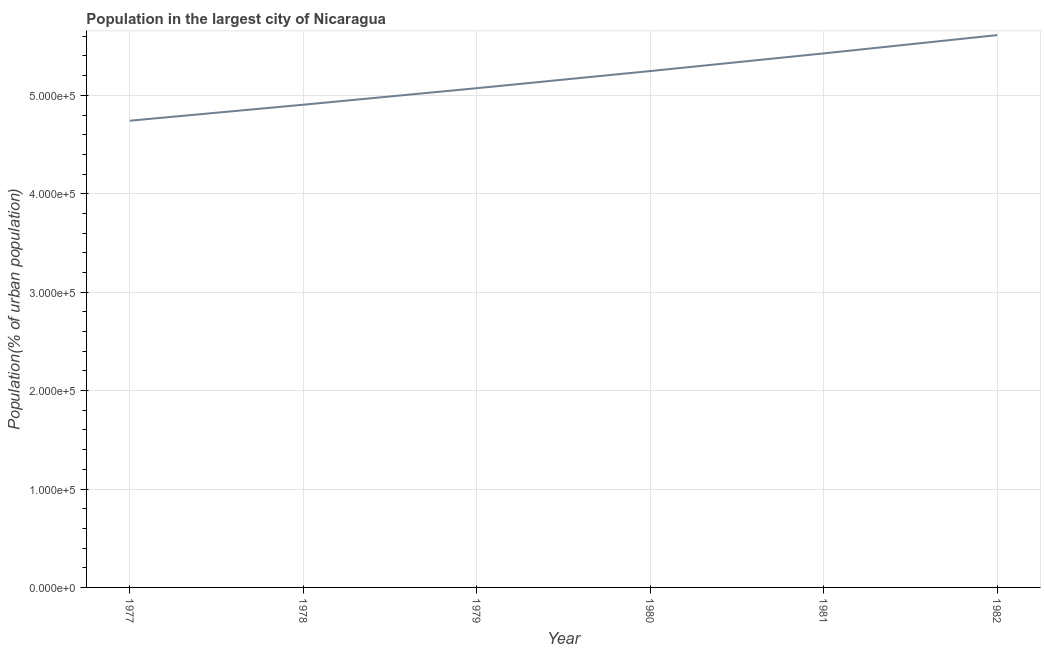What is the population in largest city in 1978?
Offer a terse response. 4.90e+05. Across all years, what is the maximum population in largest city?
Give a very brief answer. 5.61e+05. Across all years, what is the minimum population in largest city?
Your response must be concise. 4.74e+05. In which year was the population in largest city maximum?
Provide a succinct answer. 1982. In which year was the population in largest city minimum?
Offer a terse response. 1977. What is the sum of the population in largest city?
Offer a very short reply. 3.10e+06. What is the difference between the population in largest city in 1978 and 1982?
Your answer should be compact. -7.07e+04. What is the average population in largest city per year?
Keep it short and to the point. 5.17e+05. What is the median population in largest city?
Make the answer very short. 5.16e+05. In how many years, is the population in largest city greater than 60000 %?
Give a very brief answer. 6. Do a majority of the years between 1977 and 1981 (inclusive) have population in largest city greater than 480000 %?
Your answer should be compact. Yes. What is the ratio of the population in largest city in 1977 to that in 1979?
Ensure brevity in your answer.  0.93. Is the difference between the population in largest city in 1978 and 1980 greater than the difference between any two years?
Provide a succinct answer. No. What is the difference between the highest and the second highest population in largest city?
Your answer should be very brief. 1.86e+04. Is the sum of the population in largest city in 1977 and 1979 greater than the maximum population in largest city across all years?
Give a very brief answer. Yes. What is the difference between the highest and the lowest population in largest city?
Offer a very short reply. 8.70e+04. In how many years, is the population in largest city greater than the average population in largest city taken over all years?
Your response must be concise. 3. How many lines are there?
Your response must be concise. 1. How many years are there in the graph?
Your answer should be compact. 6. Are the values on the major ticks of Y-axis written in scientific E-notation?
Your response must be concise. Yes. Does the graph contain grids?
Keep it short and to the point. Yes. What is the title of the graph?
Keep it short and to the point. Population in the largest city of Nicaragua. What is the label or title of the Y-axis?
Your answer should be very brief. Population(% of urban population). What is the Population(% of urban population) in 1977?
Your answer should be very brief. 4.74e+05. What is the Population(% of urban population) of 1978?
Your response must be concise. 4.90e+05. What is the Population(% of urban population) of 1979?
Give a very brief answer. 5.07e+05. What is the Population(% of urban population) of 1980?
Provide a succinct answer. 5.25e+05. What is the Population(% of urban population) in 1981?
Provide a succinct answer. 5.43e+05. What is the Population(% of urban population) in 1982?
Keep it short and to the point. 5.61e+05. What is the difference between the Population(% of urban population) in 1977 and 1978?
Offer a terse response. -1.62e+04. What is the difference between the Population(% of urban population) in 1977 and 1979?
Give a very brief answer. -3.30e+04. What is the difference between the Population(% of urban population) in 1977 and 1980?
Keep it short and to the point. -5.04e+04. What is the difference between the Population(% of urban population) in 1977 and 1981?
Offer a terse response. -6.84e+04. What is the difference between the Population(% of urban population) in 1977 and 1982?
Provide a succinct answer. -8.70e+04. What is the difference between the Population(% of urban population) in 1978 and 1979?
Offer a very short reply. -1.68e+04. What is the difference between the Population(% of urban population) in 1978 and 1980?
Your answer should be very brief. -3.42e+04. What is the difference between the Population(% of urban population) in 1978 and 1981?
Provide a succinct answer. -5.22e+04. What is the difference between the Population(% of urban population) in 1978 and 1982?
Provide a succinct answer. -7.07e+04. What is the difference between the Population(% of urban population) in 1979 and 1980?
Give a very brief answer. -1.74e+04. What is the difference between the Population(% of urban population) in 1979 and 1981?
Make the answer very short. -3.53e+04. What is the difference between the Population(% of urban population) in 1979 and 1982?
Your answer should be compact. -5.39e+04. What is the difference between the Population(% of urban population) in 1980 and 1981?
Keep it short and to the point. -1.79e+04. What is the difference between the Population(% of urban population) in 1980 and 1982?
Ensure brevity in your answer.  -3.65e+04. What is the difference between the Population(% of urban population) in 1981 and 1982?
Provide a succinct answer. -1.86e+04. What is the ratio of the Population(% of urban population) in 1977 to that in 1978?
Give a very brief answer. 0.97. What is the ratio of the Population(% of urban population) in 1977 to that in 1979?
Provide a succinct answer. 0.94. What is the ratio of the Population(% of urban population) in 1977 to that in 1980?
Offer a terse response. 0.9. What is the ratio of the Population(% of urban population) in 1977 to that in 1981?
Offer a very short reply. 0.87. What is the ratio of the Population(% of urban population) in 1977 to that in 1982?
Ensure brevity in your answer.  0.84. What is the ratio of the Population(% of urban population) in 1978 to that in 1979?
Your answer should be very brief. 0.97. What is the ratio of the Population(% of urban population) in 1978 to that in 1980?
Keep it short and to the point. 0.94. What is the ratio of the Population(% of urban population) in 1978 to that in 1981?
Offer a very short reply. 0.9. What is the ratio of the Population(% of urban population) in 1978 to that in 1982?
Your answer should be compact. 0.87. What is the ratio of the Population(% of urban population) in 1979 to that in 1981?
Provide a succinct answer. 0.94. What is the ratio of the Population(% of urban population) in 1979 to that in 1982?
Provide a succinct answer. 0.9. What is the ratio of the Population(% of urban population) in 1980 to that in 1982?
Your answer should be compact. 0.94. 